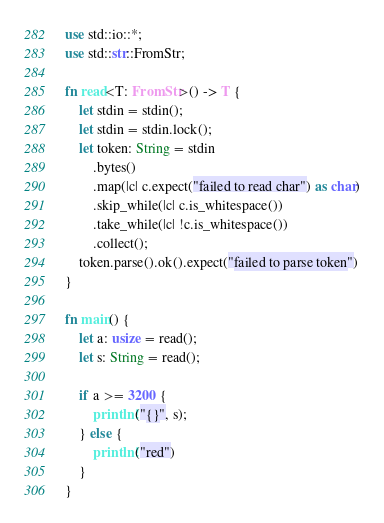<code> <loc_0><loc_0><loc_500><loc_500><_Rust_>use std::io::*;
use std::str::FromStr;

fn read<T: FromStr>() -> T {
    let stdin = stdin();
    let stdin = stdin.lock();
    let token: String = stdin
        .bytes()
        .map(|c| c.expect("failed to read char") as char)
        .skip_while(|c| c.is_whitespace())
        .take_while(|c| !c.is_whitespace())
        .collect();
    token.parse().ok().expect("failed to parse token")
}

fn main() {
    let a: usize = read();
    let s: String = read();

    if a >= 3200 {
        println!("{}", s);
    } else {
        println!("red")
    }
}
</code> 